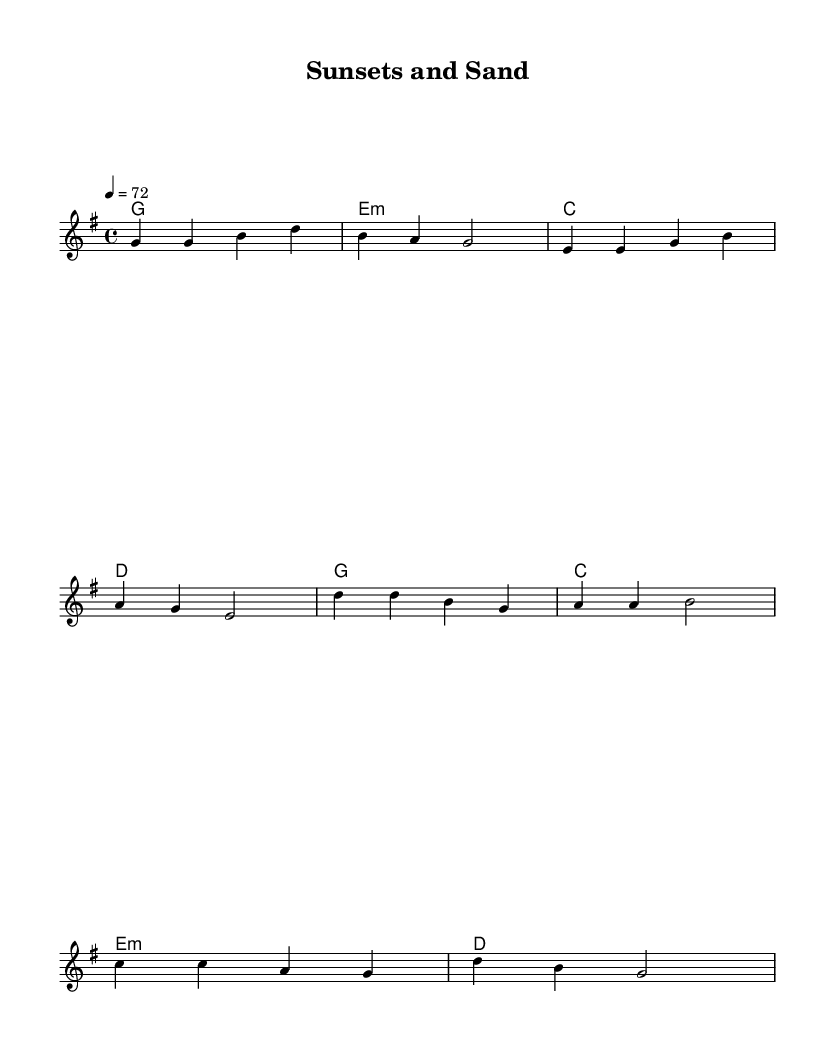What is the key signature of this music? The key signature shows one sharp (F#), indicating the piece is in G major.
Answer: G major What is the time signature of this music? The time signature appears at the beginning and shows a '4/4', meaning there are four beats in each measure.
Answer: 4/4 What is the tempo marking in this music? The tempo marking indicates a speed of '4 = 72', which means there are 72 quarter notes per minute.
Answer: 72 How many measures are in the verse section? By counting the measures in the melody section labeled as the verse, there are four measures present.
Answer: 4 What are the primary chords used in the verse section? The verse section features the chords G, E minor, C, and D, as labeled under the harmonies.
Answer: G, E minor, C, D How does the melody begin in the verse section? The melody starts on the note G and moves upward to G again, then progresses to B and D.
Answer: G What style is this music classified under? The style is identified as 'Country Rock', characterized by its laid-back feel and accessibility for relaxation.
Answer: Country Rock 